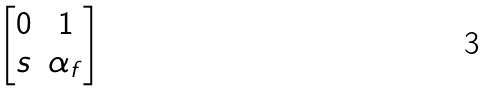<formula> <loc_0><loc_0><loc_500><loc_500>\begin{bmatrix} 0 & 1 \\ s & \alpha _ { f } \end{bmatrix}</formula> 